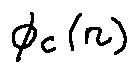Convert formula to latex. <formula><loc_0><loc_0><loc_500><loc_500>\phi _ { c } ( n )</formula> 